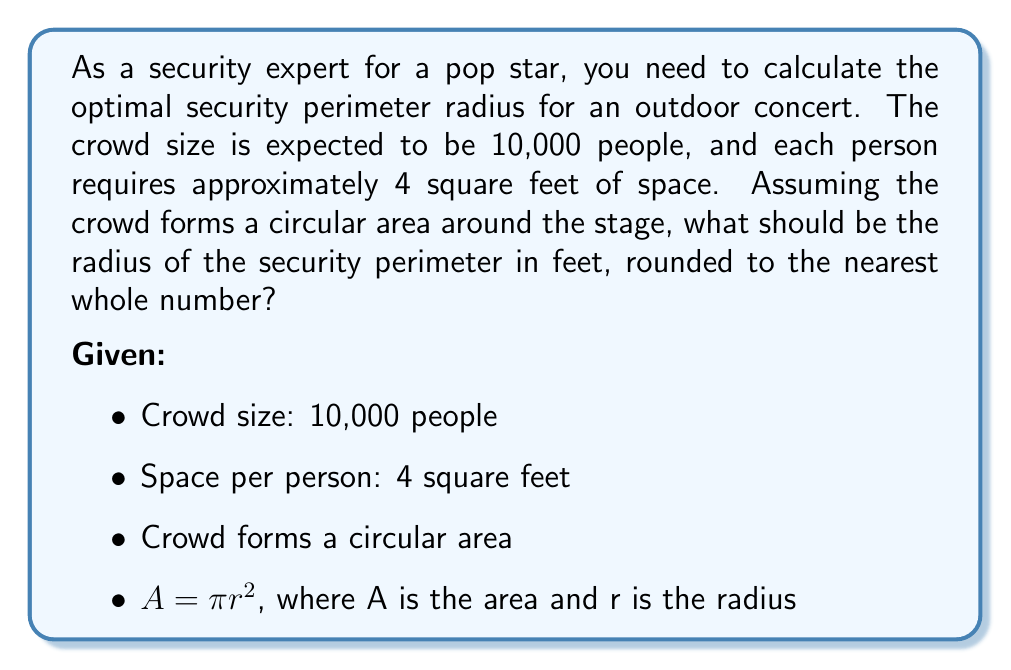What is the answer to this math problem? To solve this problem, we'll follow these steps:

1. Calculate the total area required for the crowd:
   $$A_{total} = 10,000 \text{ people} \times 4 \text{ sq ft/person} = 40,000 \text{ sq ft}$$

2. Use the area formula for a circle to find the radius:
   $$A = \pi r^2$$
   $$40,000 = \pi r^2$$

3. Solve for r:
   $$r^2 = \frac{40,000}{\pi}$$
   $$r = \sqrt{\frac{40,000}{\pi}}$$

4. Calculate the value:
   $$r = \sqrt{\frac{40,000}{3.14159}} \approx 112.8378$$

5. Round to the nearest whole number:
   $$r \approx 113 \text{ feet}$$

Therefore, the optimal security perimeter radius should be 113 feet to accommodate the expected crowd size.
Answer: 113 feet 